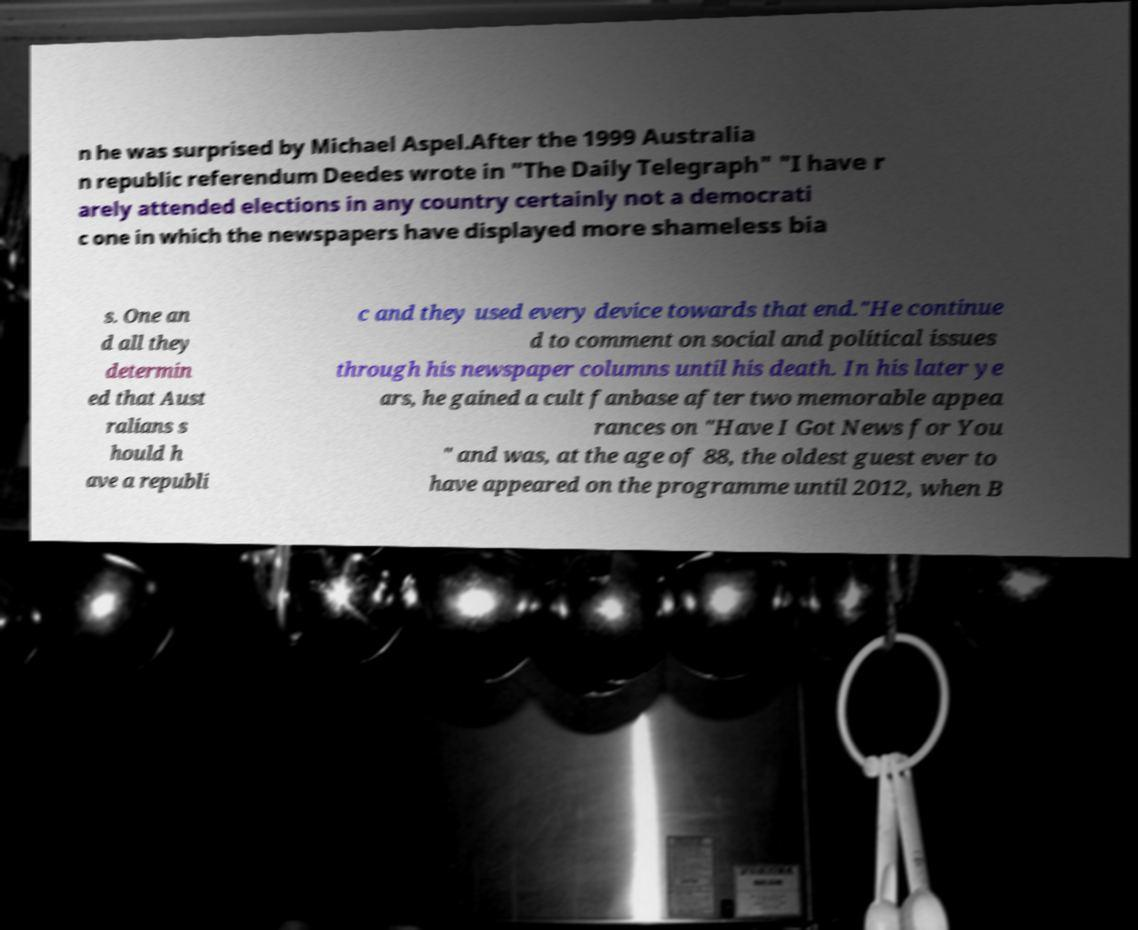Can you read and provide the text displayed in the image?This photo seems to have some interesting text. Can you extract and type it out for me? n he was surprised by Michael Aspel.After the 1999 Australia n republic referendum Deedes wrote in "The Daily Telegraph" "I have r arely attended elections in any country certainly not a democrati c one in which the newspapers have displayed more shameless bia s. One an d all they determin ed that Aust ralians s hould h ave a republi c and they used every device towards that end."He continue d to comment on social and political issues through his newspaper columns until his death. In his later ye ars, he gained a cult fanbase after two memorable appea rances on "Have I Got News for You " and was, at the age of 88, the oldest guest ever to have appeared on the programme until 2012, when B 